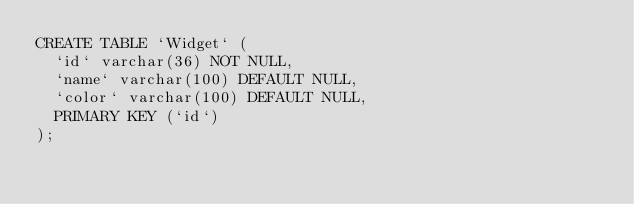Convert code to text. <code><loc_0><loc_0><loc_500><loc_500><_SQL_>CREATE TABLE `Widget` (
  `id` varchar(36) NOT NULL,
  `name` varchar(100) DEFAULT NULL,
  `color` varchar(100) DEFAULT NULL,
  PRIMARY KEY (`id`)
);
</code> 